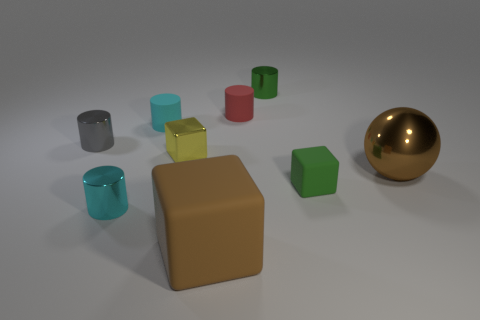Is the number of cyan cylinders less than the number of large gray shiny cubes?
Make the answer very short. No. What color is the rubber block left of the tiny green rubber cube?
Ensure brevity in your answer.  Brown. There is a thing that is right of the green metal thing and to the left of the brown shiny thing; what is its material?
Provide a succinct answer. Rubber. The cyan object that is the same material as the tiny gray object is what shape?
Your answer should be compact. Cylinder. There is a tiny block that is left of the red cylinder; what number of tiny red matte cylinders are left of it?
Offer a very short reply. 0. What number of small cylinders are both on the left side of the tiny green shiny object and to the right of the brown block?
Ensure brevity in your answer.  1. How many other objects are the same material as the green cylinder?
Your response must be concise. 4. What color is the metal cylinder to the right of the large object in front of the big ball?
Ensure brevity in your answer.  Green. There is a object that is to the right of the small matte cube; does it have the same color as the large matte block?
Ensure brevity in your answer.  Yes. Is the shiny block the same size as the gray cylinder?
Keep it short and to the point. Yes. 